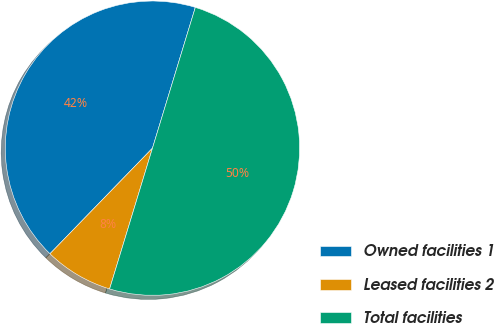<chart> <loc_0><loc_0><loc_500><loc_500><pie_chart><fcel>Owned facilities 1<fcel>Leased facilities 2<fcel>Total facilities<nl><fcel>42.44%<fcel>7.56%<fcel>50.0%<nl></chart> 